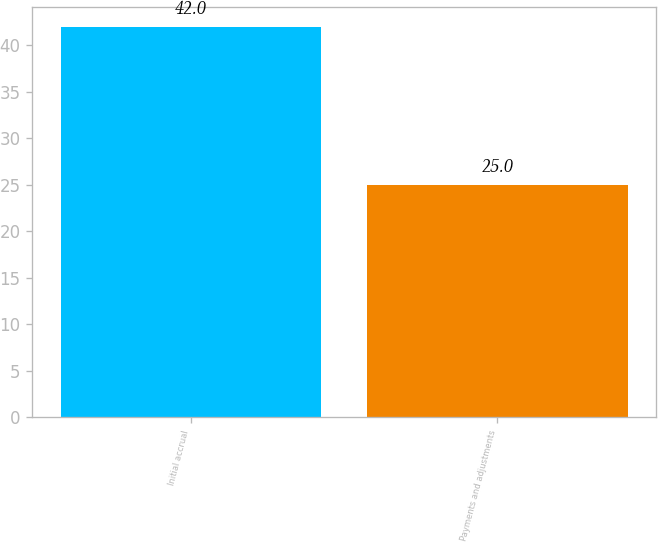Convert chart. <chart><loc_0><loc_0><loc_500><loc_500><bar_chart><fcel>Initial accrual<fcel>Payments and adjustments<nl><fcel>42<fcel>25<nl></chart> 